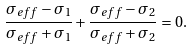Convert formula to latex. <formula><loc_0><loc_0><loc_500><loc_500>\frac { \sigma _ { e f f } - \sigma _ { 1 } } { \sigma _ { e f f } + \sigma _ { 1 } } + \frac { \sigma _ { e f f } - \sigma _ { 2 } } { \sigma _ { e f f } + \sigma _ { 2 } } = 0 .</formula> 